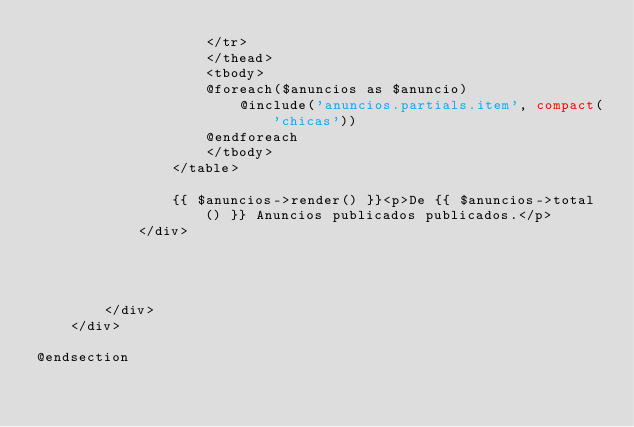<code> <loc_0><loc_0><loc_500><loc_500><_PHP_>                    </tr>
                    </thead>
                    <tbody>
                    @foreach($anuncios as $anuncio)
                        @include('anuncios.partials.item', compact('chicas'))
                    @endforeach
                    </tbody>
                </table>

                {{ $anuncios->render() }}<p>De {{ $anuncios->total() }} Anuncios publicados publicados.</p>
            </div>




        </div>
    </div>

@endsection</code> 